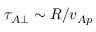<formula> <loc_0><loc_0><loc_500><loc_500>\tau _ { A \perp } \sim R / v _ { A p }</formula> 